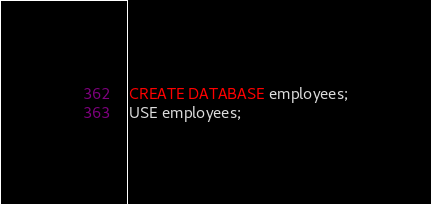<code> <loc_0><loc_0><loc_500><loc_500><_SQL_>CREATE DATABASE employees;
USE employees;
</code> 